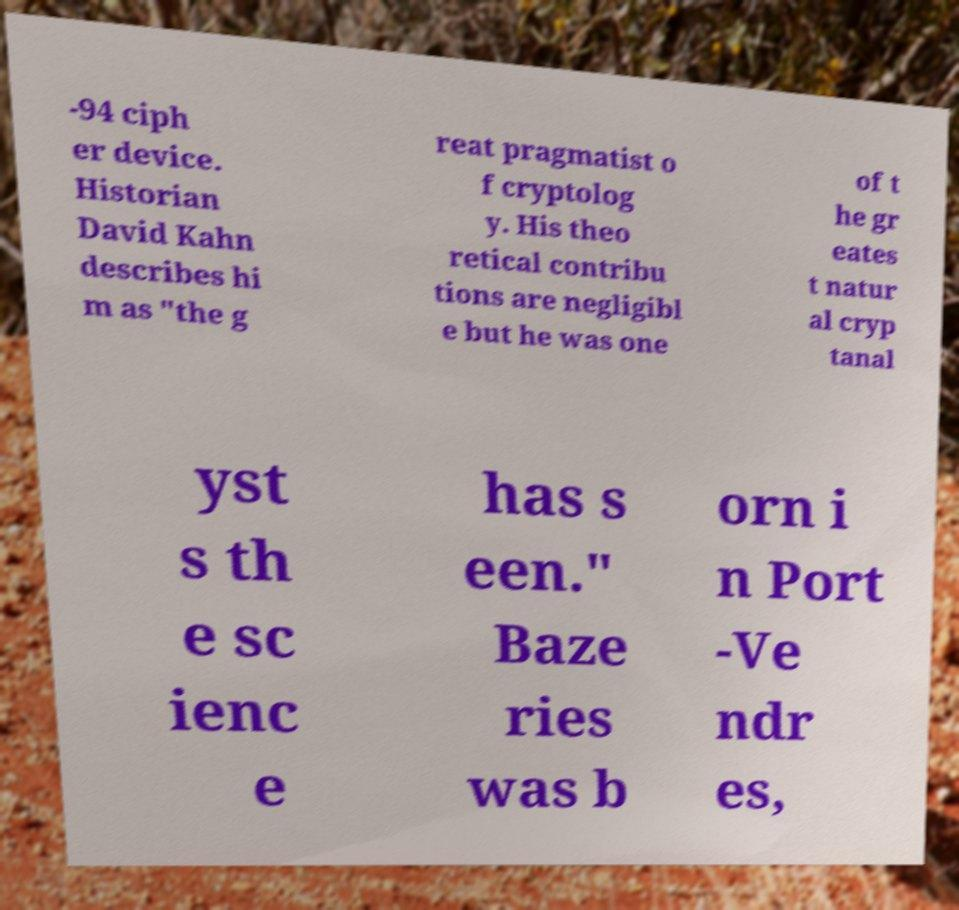For documentation purposes, I need the text within this image transcribed. Could you provide that? -94 ciph er device. Historian David Kahn describes hi m as "the g reat pragmatist o f cryptolog y. His theo retical contribu tions are negligibl e but he was one of t he gr eates t natur al cryp tanal yst s th e sc ienc e has s een." Baze ries was b orn i n Port -Ve ndr es, 